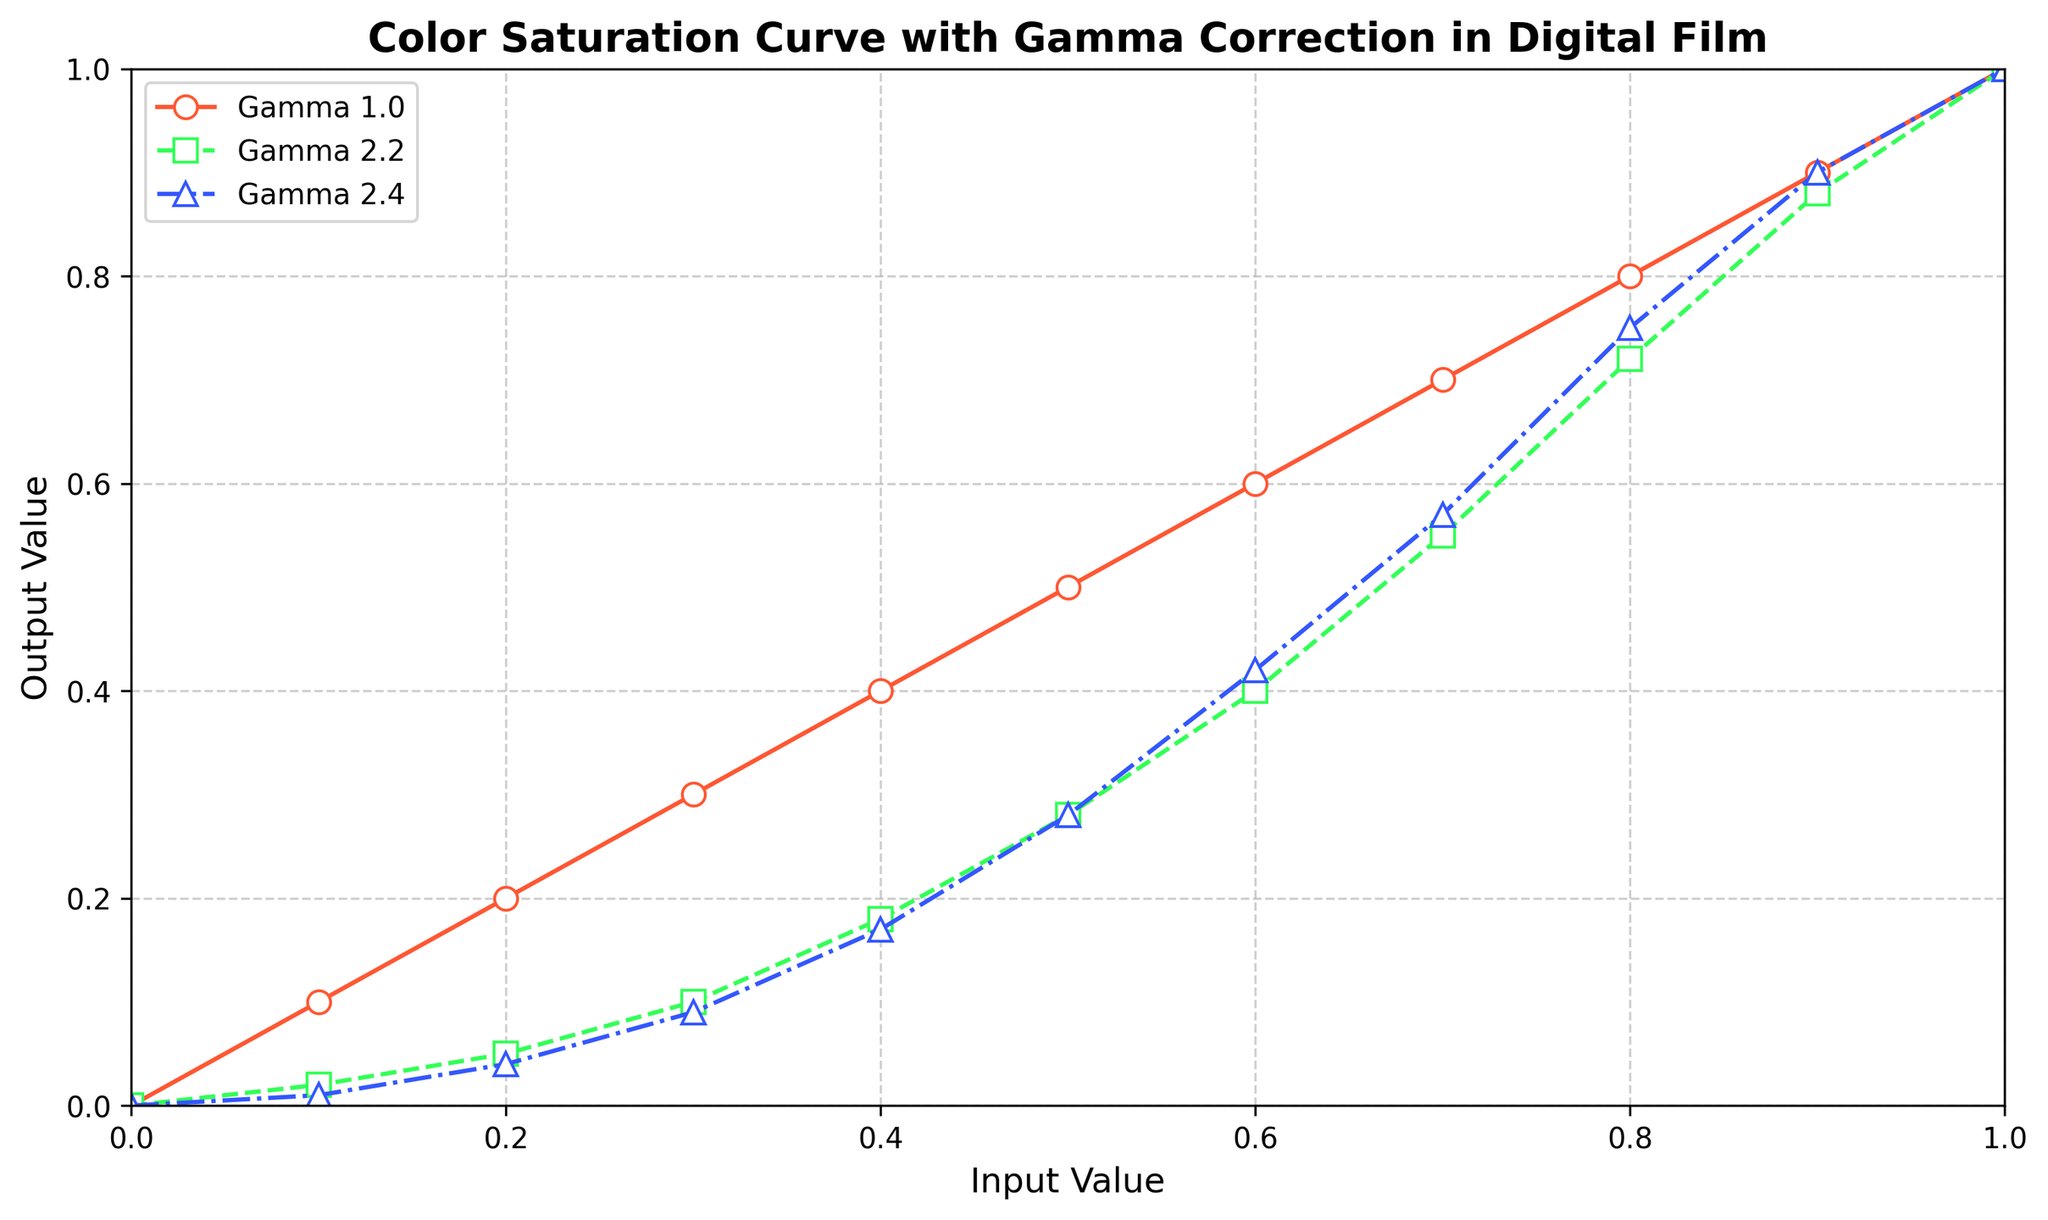What is the output value for an input value of 0.5 with a gamma value of 2.4? Locate the curve labeled 'Gamma 2.4', then find where the input value of 0.5 intersects this curve. The corresponding output value from the y-axis is the answer.
Answer: 0.28 How does the shape of the curve for gamma 2.2 differ from gamma 1.0? Compare the two curves. The gamma 1.0 curve is linear (a straight line), while the gamma 2.2 curve is non-linear and concave towards the origin, indicating a slower initial increase in output values compared to input values.
Answer: Non-linear vs Linear At which gamma value does the output value reach 0.88 for an input value of 0.9? Identify the input value of 0.9 on the x-axis, then check which gamma curve intersects this input value at the output value of 0.88 on the y-axis.
Answer: 2.2 What is the overall trend in output values as the gamma value increases? Observe the curves for increasing gamma values (1.0, 2.2, 2.4). As the gamma value increases, the curve becomes more concave, indicating that output values increase more gradually for lower input values.
Answer: More gradual increase For the gamma 2.4 curve, what is the difference in output values between input values of 0.7 and 0.8? Locate the output values for input values of 0.7 and 0.8 on the gamma 2.4 curve (0.57 and 0.75, respectively) and find their difference by subtracting the former from the latter.
Answer: 0.18 What is the color used for the gamma 1.0 curve? The color attribute of the gamma 1.0 curve can be identified visually from the plot.
Answer: Red For gamma 2.4, what is the ratio of the output value at an input of 0.3 to the output value at an input of 0.2? Locate the output values for input values of 0.3 and 0.2 on the gamma 2.4 curve (0.09 and 0.04, respectively) and compute the ratio by dividing the former by the latter.
Answer: 2.25 Which gamma value curve has the steepest initial increase in output value? Identify how steeply the curves rise from the origin; the gamma 1.0 curve rises linearly, while higher gamma values rise more slowly initially.
Answer: 1.0 